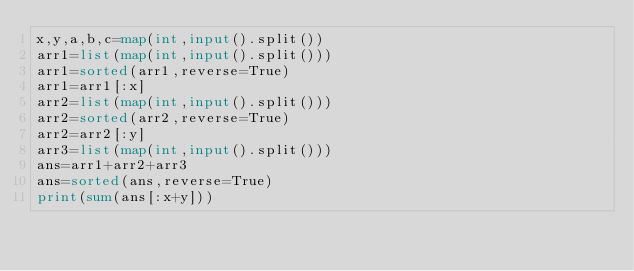Convert code to text. <code><loc_0><loc_0><loc_500><loc_500><_Python_>x,y,a,b,c=map(int,input().split())
arr1=list(map(int,input().split()))
arr1=sorted(arr1,reverse=True)
arr1=arr1[:x]
arr2=list(map(int,input().split()))
arr2=sorted(arr2,reverse=True)
arr2=arr2[:y]
arr3=list(map(int,input().split()))
ans=arr1+arr2+arr3
ans=sorted(ans,reverse=True)
print(sum(ans[:x+y]))</code> 